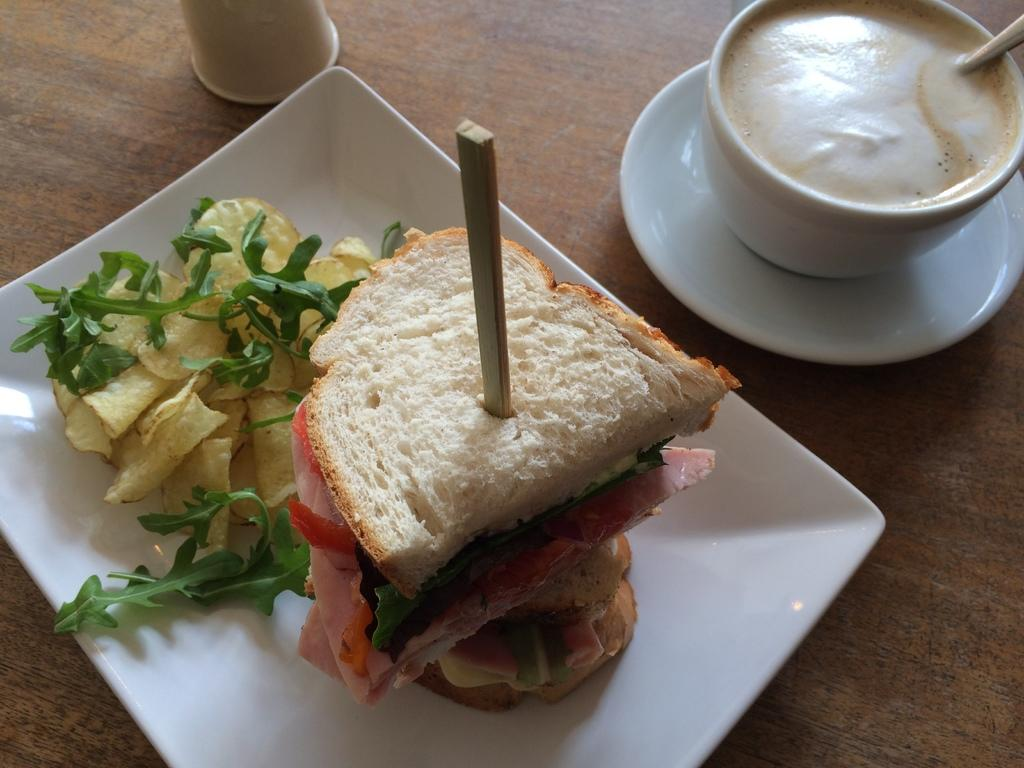What is on the white tray in the image? There is food on a white tray in the image. What type of container is present in the image? There is a container in the image. What beverage is visible in the image? There is coffee in the image. What utensil is present in the image? There is a spoon in the image. What type of cup is in the image? There is a cup in the image. What is the saucer used for in the image? The saucer is used to hold the cup in the image. What is the surface that the items are placed on? The items are placed on a wooden surface. Can you see any magic happening with the food on the tray in the image? There is no magic present in the image; it is a regular tray with food. Are there any feathers visible in the image? There are no feathers present in the image. 